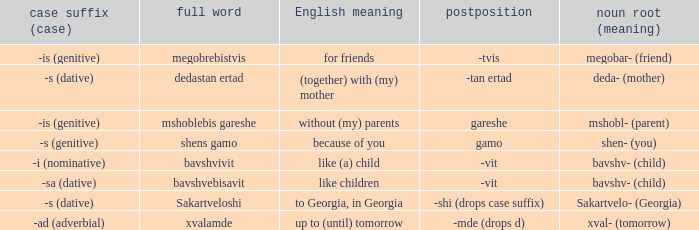What is English Meaning, when Case Suffix (Case) is "-sa (dative)"? Like children. 